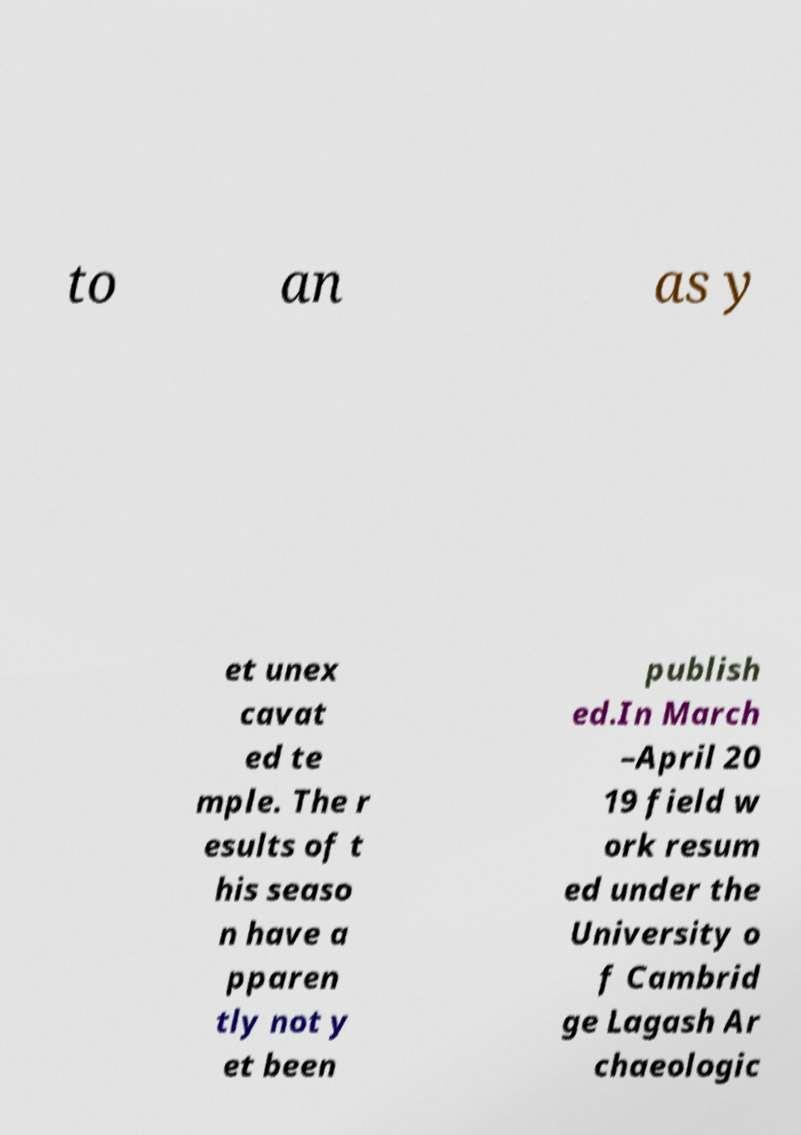There's text embedded in this image that I need extracted. Can you transcribe it verbatim? to an as y et unex cavat ed te mple. The r esults of t his seaso n have a pparen tly not y et been publish ed.In March –April 20 19 field w ork resum ed under the University o f Cambrid ge Lagash Ar chaeologic 